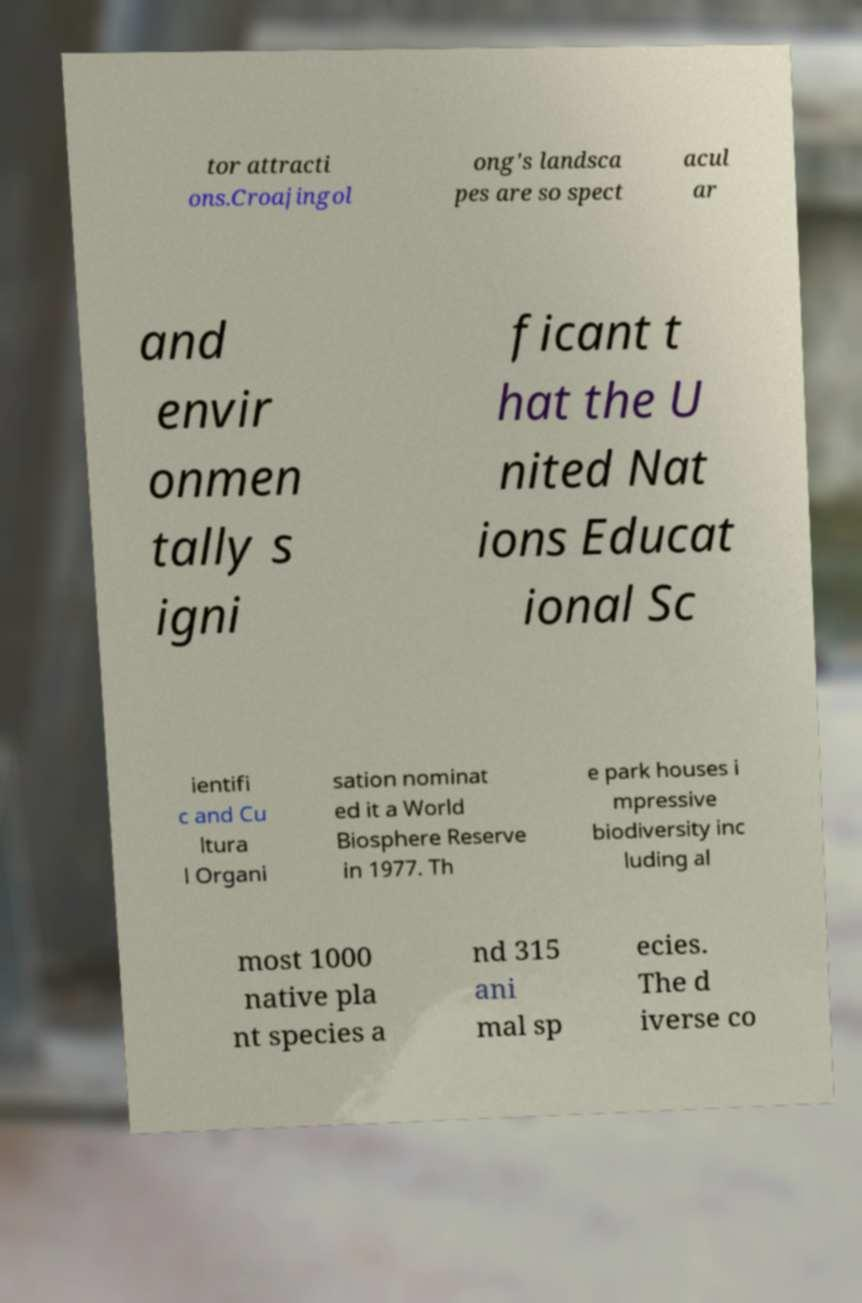Can you accurately transcribe the text from the provided image for me? tor attracti ons.Croajingol ong's landsca pes are so spect acul ar and envir onmen tally s igni ficant t hat the U nited Nat ions Educat ional Sc ientifi c and Cu ltura l Organi sation nominat ed it a World Biosphere Reserve in 1977. Th e park houses i mpressive biodiversity inc luding al most 1000 native pla nt species a nd 315 ani mal sp ecies. The d iverse co 